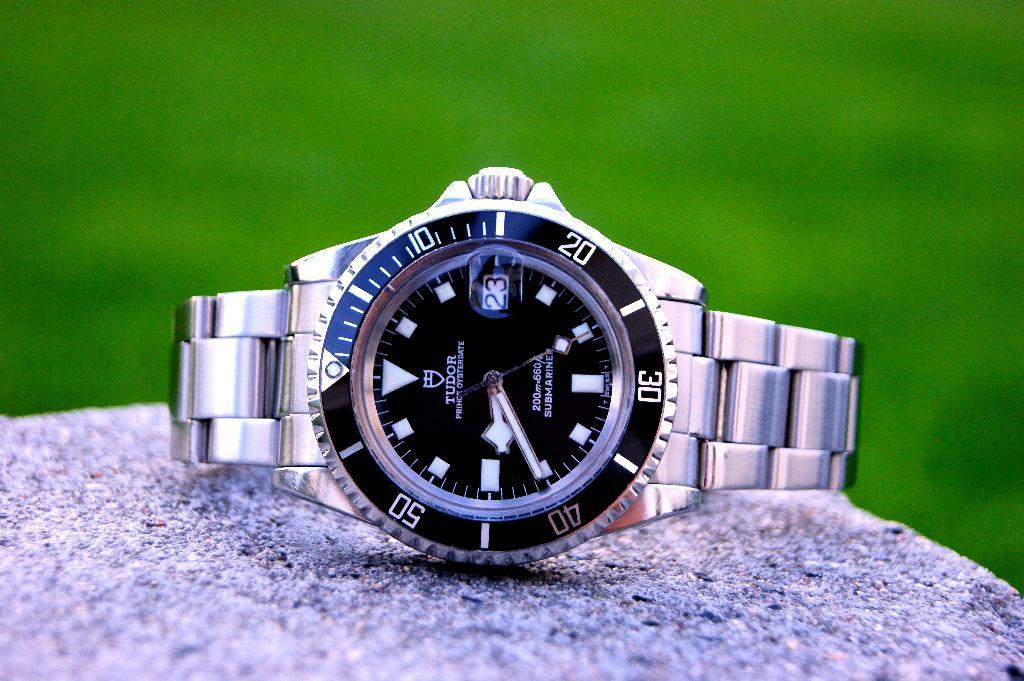<image>
Write a terse but informative summary of the picture. A Tudor brand watch is displayed atop a rock. 